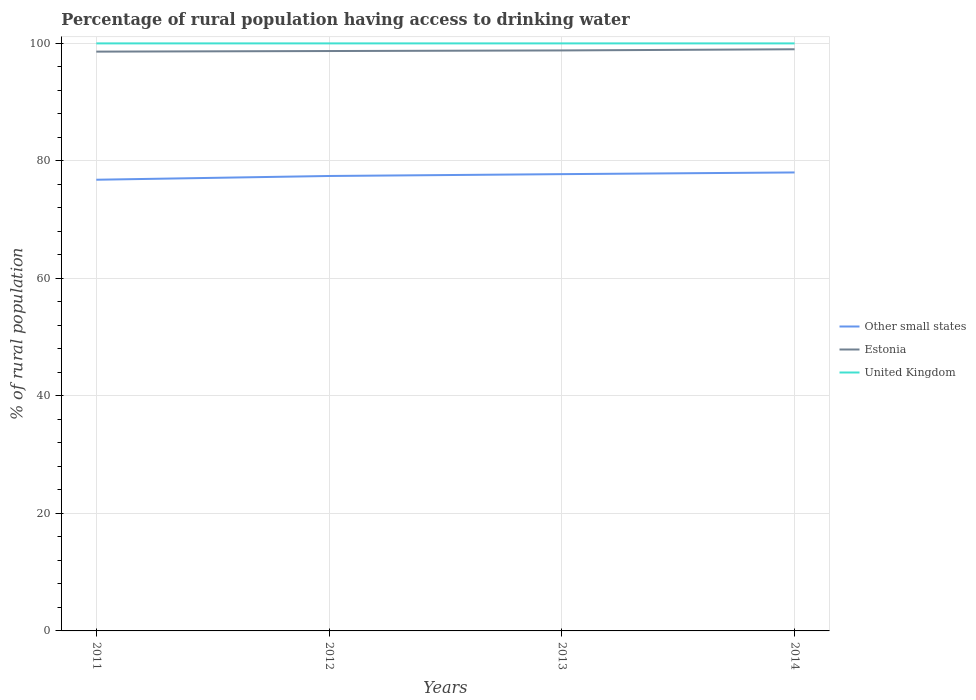Does the line corresponding to Other small states intersect with the line corresponding to United Kingdom?
Your response must be concise. No. Across all years, what is the maximum percentage of rural population having access to drinking water in United Kingdom?
Keep it short and to the point. 100. What is the total percentage of rural population having access to drinking water in Estonia in the graph?
Provide a succinct answer. -0.4. How many years are there in the graph?
Provide a succinct answer. 4. Are the values on the major ticks of Y-axis written in scientific E-notation?
Make the answer very short. No. Does the graph contain any zero values?
Offer a very short reply. No. Does the graph contain grids?
Give a very brief answer. Yes. Where does the legend appear in the graph?
Ensure brevity in your answer.  Center right. What is the title of the graph?
Your answer should be compact. Percentage of rural population having access to drinking water. Does "Turks and Caicos Islands" appear as one of the legend labels in the graph?
Provide a succinct answer. No. What is the label or title of the Y-axis?
Keep it short and to the point. % of rural population. What is the % of rural population of Other small states in 2011?
Keep it short and to the point. 76.79. What is the % of rural population in Estonia in 2011?
Offer a very short reply. 98.6. What is the % of rural population in Other small states in 2012?
Offer a very short reply. 77.43. What is the % of rural population in Estonia in 2012?
Offer a very short reply. 98.7. What is the % of rural population in United Kingdom in 2012?
Your answer should be compact. 100. What is the % of rural population in Other small states in 2013?
Offer a very short reply. 77.75. What is the % of rural population in Estonia in 2013?
Make the answer very short. 98.8. What is the % of rural population of Other small states in 2014?
Keep it short and to the point. 78.03. Across all years, what is the maximum % of rural population in Other small states?
Give a very brief answer. 78.03. Across all years, what is the minimum % of rural population of Other small states?
Your answer should be compact. 76.79. Across all years, what is the minimum % of rural population of Estonia?
Your answer should be compact. 98.6. Across all years, what is the minimum % of rural population in United Kingdom?
Your answer should be very brief. 100. What is the total % of rural population of Other small states in the graph?
Give a very brief answer. 310. What is the total % of rural population in Estonia in the graph?
Offer a terse response. 395.1. What is the total % of rural population in United Kingdom in the graph?
Offer a very short reply. 400. What is the difference between the % of rural population in Other small states in 2011 and that in 2012?
Ensure brevity in your answer.  -0.64. What is the difference between the % of rural population in Estonia in 2011 and that in 2012?
Give a very brief answer. -0.1. What is the difference between the % of rural population in Other small states in 2011 and that in 2013?
Your answer should be compact. -0.95. What is the difference between the % of rural population in United Kingdom in 2011 and that in 2013?
Make the answer very short. 0. What is the difference between the % of rural population of Other small states in 2011 and that in 2014?
Ensure brevity in your answer.  -1.24. What is the difference between the % of rural population of United Kingdom in 2011 and that in 2014?
Make the answer very short. 0. What is the difference between the % of rural population of Other small states in 2012 and that in 2013?
Give a very brief answer. -0.32. What is the difference between the % of rural population in United Kingdom in 2012 and that in 2013?
Provide a short and direct response. 0. What is the difference between the % of rural population in Other small states in 2012 and that in 2014?
Give a very brief answer. -0.6. What is the difference between the % of rural population in United Kingdom in 2012 and that in 2014?
Provide a short and direct response. 0. What is the difference between the % of rural population of Other small states in 2013 and that in 2014?
Your answer should be very brief. -0.29. What is the difference between the % of rural population of United Kingdom in 2013 and that in 2014?
Provide a succinct answer. 0. What is the difference between the % of rural population of Other small states in 2011 and the % of rural population of Estonia in 2012?
Your answer should be very brief. -21.91. What is the difference between the % of rural population of Other small states in 2011 and the % of rural population of United Kingdom in 2012?
Make the answer very short. -23.21. What is the difference between the % of rural population in Other small states in 2011 and the % of rural population in Estonia in 2013?
Your response must be concise. -22.01. What is the difference between the % of rural population in Other small states in 2011 and the % of rural population in United Kingdom in 2013?
Make the answer very short. -23.21. What is the difference between the % of rural population of Other small states in 2011 and the % of rural population of Estonia in 2014?
Offer a terse response. -22.21. What is the difference between the % of rural population of Other small states in 2011 and the % of rural population of United Kingdom in 2014?
Ensure brevity in your answer.  -23.21. What is the difference between the % of rural population of Other small states in 2012 and the % of rural population of Estonia in 2013?
Keep it short and to the point. -21.37. What is the difference between the % of rural population of Other small states in 2012 and the % of rural population of United Kingdom in 2013?
Your response must be concise. -22.57. What is the difference between the % of rural population in Estonia in 2012 and the % of rural population in United Kingdom in 2013?
Provide a short and direct response. -1.3. What is the difference between the % of rural population in Other small states in 2012 and the % of rural population in Estonia in 2014?
Keep it short and to the point. -21.57. What is the difference between the % of rural population in Other small states in 2012 and the % of rural population in United Kingdom in 2014?
Provide a succinct answer. -22.57. What is the difference between the % of rural population of Estonia in 2012 and the % of rural population of United Kingdom in 2014?
Your response must be concise. -1.3. What is the difference between the % of rural population of Other small states in 2013 and the % of rural population of Estonia in 2014?
Your response must be concise. -21.25. What is the difference between the % of rural population in Other small states in 2013 and the % of rural population in United Kingdom in 2014?
Your answer should be very brief. -22.25. What is the average % of rural population of Other small states per year?
Offer a very short reply. 77.5. What is the average % of rural population in Estonia per year?
Your answer should be very brief. 98.78. What is the average % of rural population in United Kingdom per year?
Your answer should be very brief. 100. In the year 2011, what is the difference between the % of rural population of Other small states and % of rural population of Estonia?
Offer a terse response. -21.81. In the year 2011, what is the difference between the % of rural population of Other small states and % of rural population of United Kingdom?
Your answer should be very brief. -23.21. In the year 2012, what is the difference between the % of rural population of Other small states and % of rural population of Estonia?
Provide a succinct answer. -21.27. In the year 2012, what is the difference between the % of rural population in Other small states and % of rural population in United Kingdom?
Your response must be concise. -22.57. In the year 2012, what is the difference between the % of rural population in Estonia and % of rural population in United Kingdom?
Your answer should be compact. -1.3. In the year 2013, what is the difference between the % of rural population in Other small states and % of rural population in Estonia?
Ensure brevity in your answer.  -21.05. In the year 2013, what is the difference between the % of rural population of Other small states and % of rural population of United Kingdom?
Make the answer very short. -22.25. In the year 2014, what is the difference between the % of rural population of Other small states and % of rural population of Estonia?
Give a very brief answer. -20.97. In the year 2014, what is the difference between the % of rural population of Other small states and % of rural population of United Kingdom?
Provide a succinct answer. -21.97. In the year 2014, what is the difference between the % of rural population of Estonia and % of rural population of United Kingdom?
Your answer should be very brief. -1. What is the ratio of the % of rural population of Other small states in 2011 to that in 2012?
Offer a very short reply. 0.99. What is the ratio of the % of rural population of United Kingdom in 2011 to that in 2012?
Your answer should be very brief. 1. What is the ratio of the % of rural population in Other small states in 2011 to that in 2013?
Offer a very short reply. 0.99. What is the ratio of the % of rural population in United Kingdom in 2011 to that in 2013?
Ensure brevity in your answer.  1. What is the ratio of the % of rural population of Other small states in 2011 to that in 2014?
Provide a succinct answer. 0.98. What is the ratio of the % of rural population in Estonia in 2011 to that in 2014?
Provide a succinct answer. 1. What is the ratio of the % of rural population of United Kingdom in 2011 to that in 2014?
Offer a very short reply. 1. What is the ratio of the % of rural population in Other small states in 2012 to that in 2013?
Keep it short and to the point. 1. What is the ratio of the % of rural population in Other small states in 2012 to that in 2014?
Ensure brevity in your answer.  0.99. What is the ratio of the % of rural population of Estonia in 2012 to that in 2014?
Offer a very short reply. 1. What is the ratio of the % of rural population of United Kingdom in 2012 to that in 2014?
Give a very brief answer. 1. What is the ratio of the % of rural population in Other small states in 2013 to that in 2014?
Give a very brief answer. 1. What is the ratio of the % of rural population of United Kingdom in 2013 to that in 2014?
Your answer should be compact. 1. What is the difference between the highest and the second highest % of rural population in Other small states?
Provide a succinct answer. 0.29. What is the difference between the highest and the second highest % of rural population of United Kingdom?
Offer a very short reply. 0. What is the difference between the highest and the lowest % of rural population in Other small states?
Your response must be concise. 1.24. What is the difference between the highest and the lowest % of rural population in Estonia?
Your answer should be very brief. 0.4. 